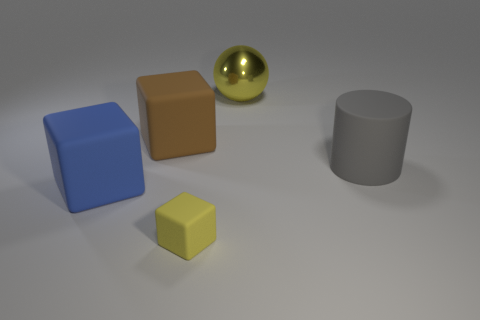Add 3 small brown blocks. How many objects exist? 8 Subtract all balls. How many objects are left? 4 Add 5 tiny yellow things. How many tiny yellow things are left? 6 Add 2 tiny brown shiny cylinders. How many tiny brown shiny cylinders exist? 2 Subtract 0 green cylinders. How many objects are left? 5 Subtract all green things. Subtract all large rubber cubes. How many objects are left? 3 